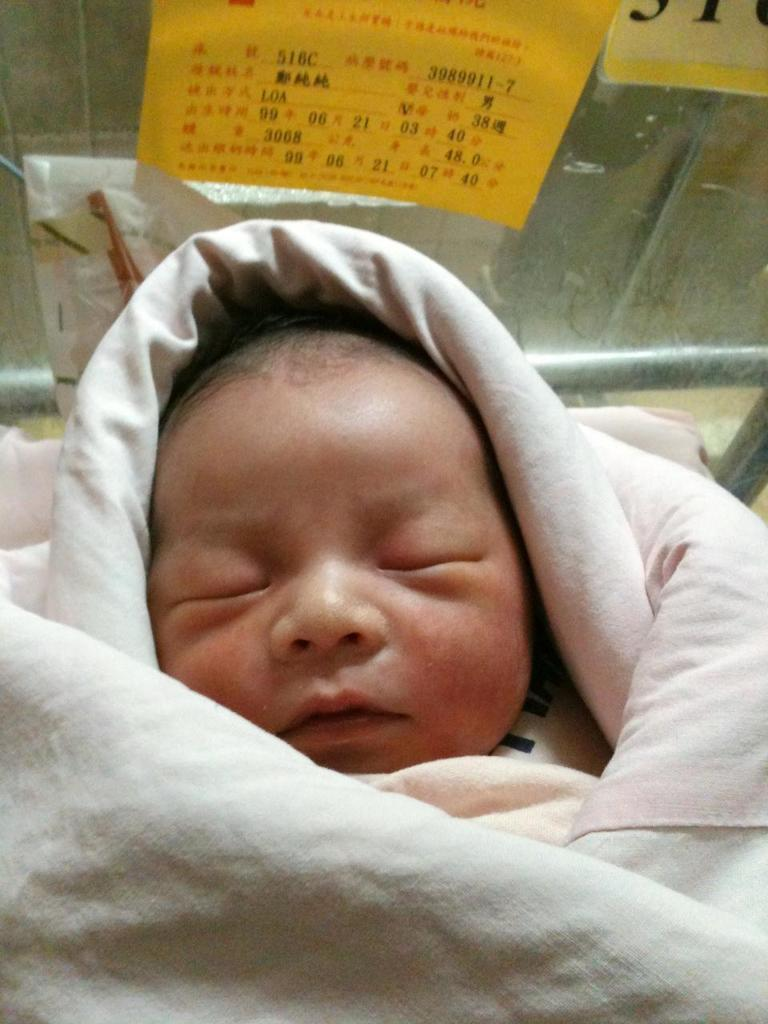What is the main subject of the image? There is a baby sleeping in the image. What is covering the baby in the image? There is a blanket in the image. What can be seen in the background of the image? There are posts with text on the wall in the background of the image. What type of sack is being carried by the person in the image? There is no person or sack present in the image; it only features a baby sleeping with a blanket. 